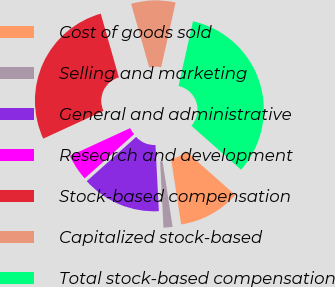Convert chart. <chart><loc_0><loc_0><loc_500><loc_500><pie_chart><fcel>Cost of goods sold<fcel>Selling and marketing<fcel>General and administrative<fcel>Research and development<fcel>Stock-based compensation<fcel>Capitalized stock-based<fcel>Total stock-based compensation<nl><fcel>11.04%<fcel>1.61%<fcel>14.19%<fcel>4.75%<fcel>27.46%<fcel>7.9%<fcel>33.05%<nl></chart> 